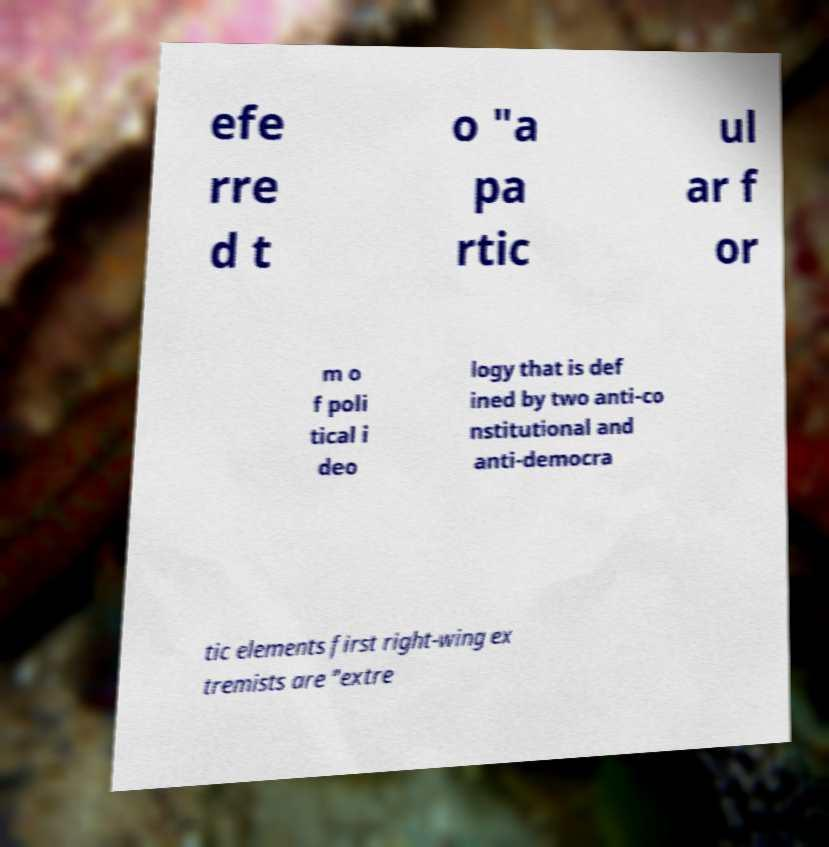Please read and relay the text visible in this image. What does it say? efe rre d t o "a pa rtic ul ar f or m o f poli tical i deo logy that is def ined by two anti-co nstitutional and anti-democra tic elements first right-wing ex tremists are "extre 